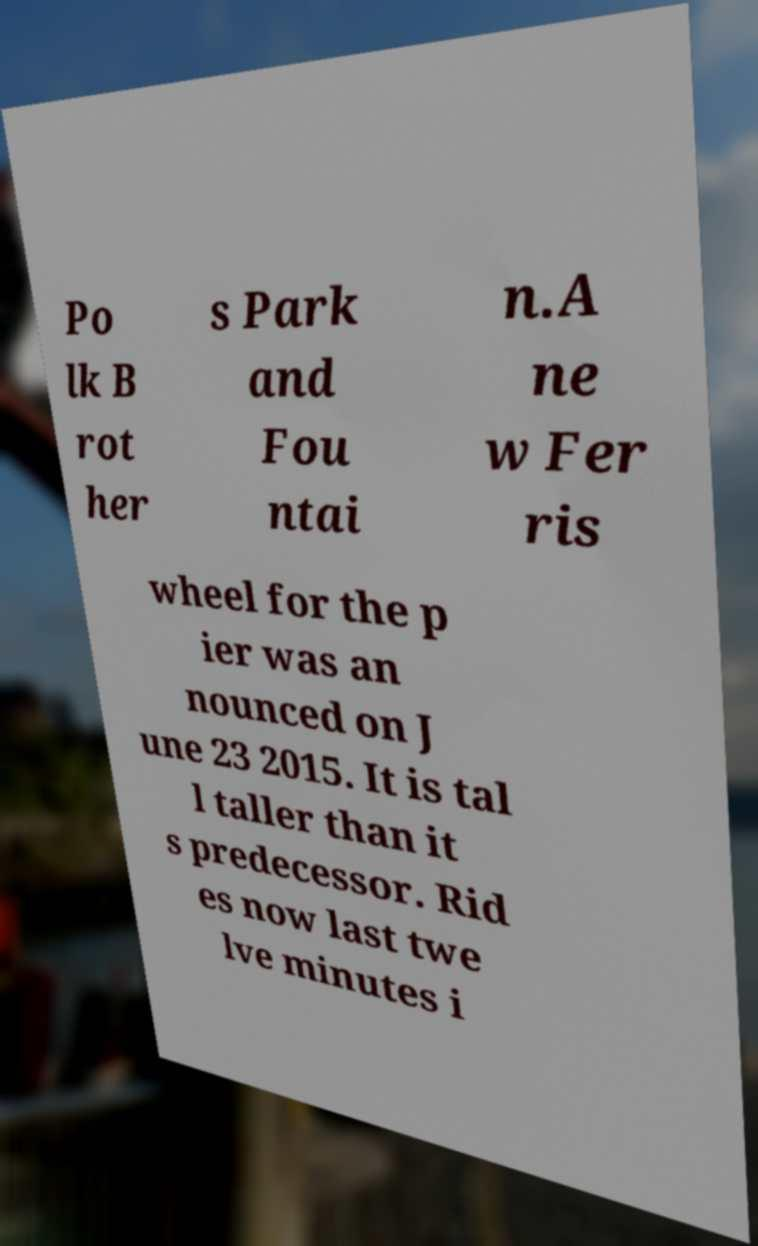What messages or text are displayed in this image? I need them in a readable, typed format. Po lk B rot her s Park and Fou ntai n.A ne w Fer ris wheel for the p ier was an nounced on J une 23 2015. It is tal l taller than it s predecessor. Rid es now last twe lve minutes i 